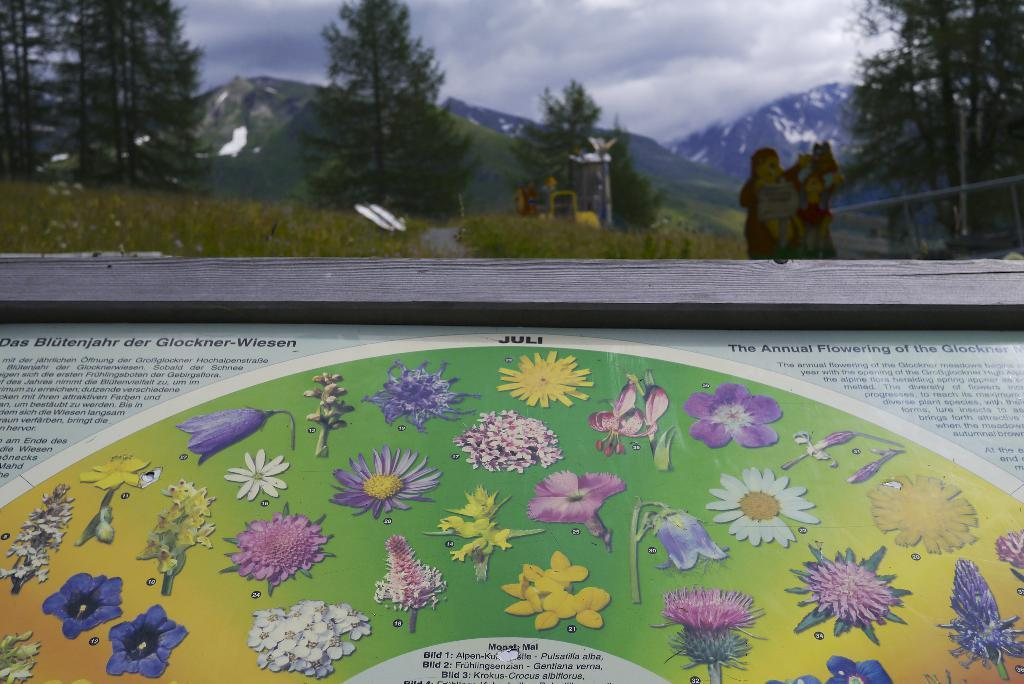What type of object with text is present in the image? There is a wooden object with text in the image. What can be seen in the background of the image? There are trees, mountains, and the sky visible in the background of the image. How much salt is present on the wooden object in the image? There is no salt present on the wooden object in the image. Is there a bear visible in the image? No, there is no bear present in the image. 